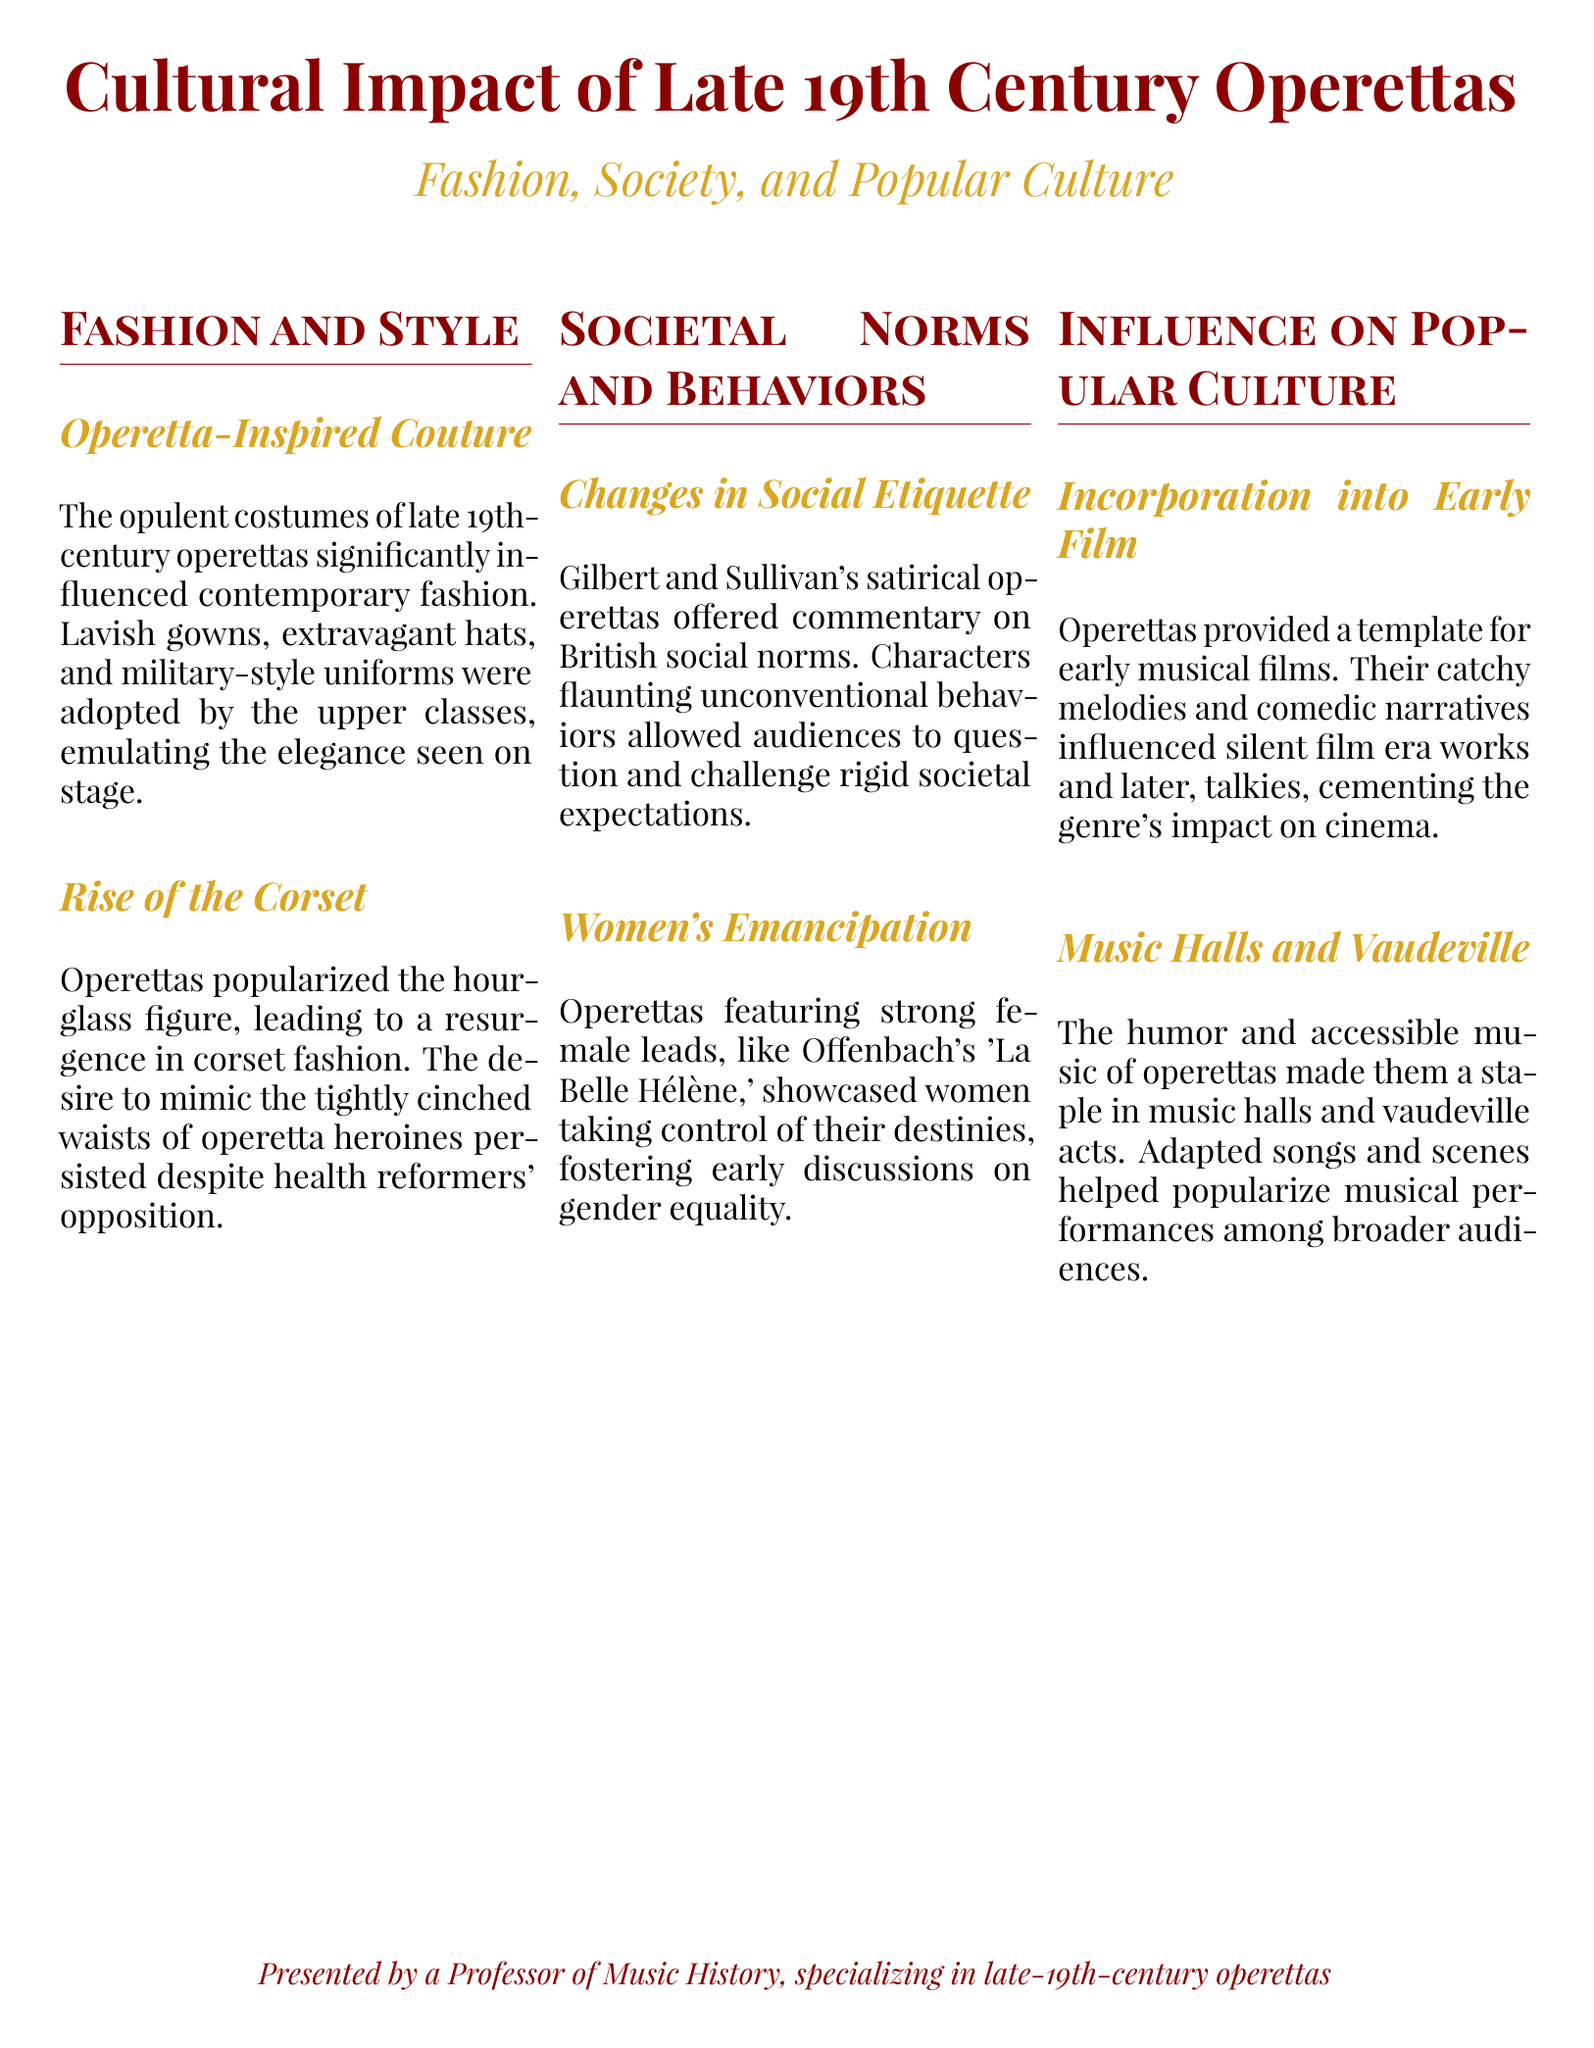what influenced contemporary fashion in operettas? The document mentions that opulent costumes significantly influenced contemporary fashion.
Answer: opulent costumes what popular item of clothing rose in popularity due to operettas? The document discusses the resurgence of corset fashion associated with operettas.
Answer: corset which operetta featured strong female leads? The document cites "La Belle Hélène" as an example showcasing strong female leads.
Answer: La Belle Hélène how did Gilbert and Sullivan's operettas affect social norms? The document states that their operettas offered commentary on British social norms, prompting audiences to challenge expectations.
Answer: social norms what musical genre did operettas influence in early cinema? The document indicates that operettas provided a template for early musical films.
Answer: musical films how did operettas contribute to vaudeville? The document explains that operettas' humor and music made them staples in vaudeville acts.
Answer: staples in vaudeville acts 